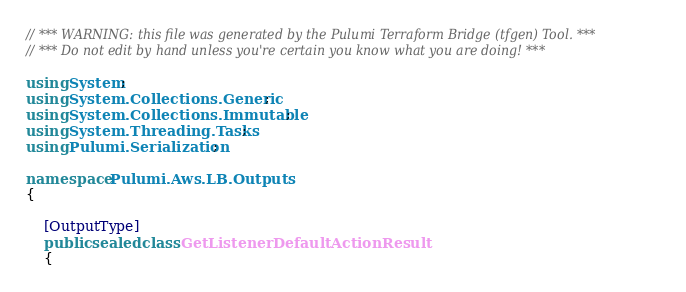<code> <loc_0><loc_0><loc_500><loc_500><_C#_>// *** WARNING: this file was generated by the Pulumi Terraform Bridge (tfgen) Tool. ***
// *** Do not edit by hand unless you're certain you know what you are doing! ***

using System;
using System.Collections.Generic;
using System.Collections.Immutable;
using System.Threading.Tasks;
using Pulumi.Serialization;

namespace Pulumi.Aws.LB.Outputs
{

    [OutputType]
    public sealed class GetListenerDefaultActionResult
    {</code> 